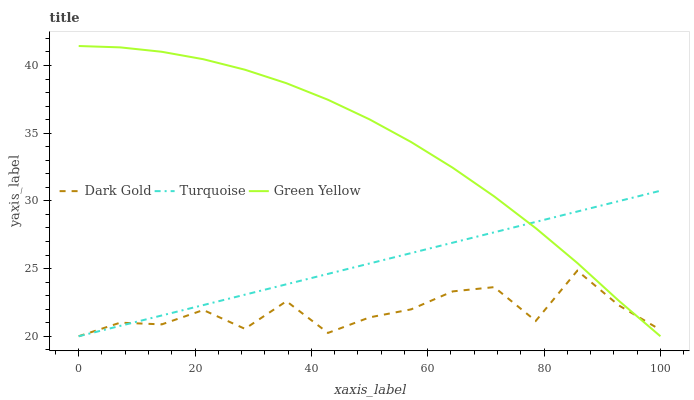Does Dark Gold have the minimum area under the curve?
Answer yes or no. Yes. Does Green Yellow have the maximum area under the curve?
Answer yes or no. Yes. Does Green Yellow have the minimum area under the curve?
Answer yes or no. No. Does Dark Gold have the maximum area under the curve?
Answer yes or no. No. Is Turquoise the smoothest?
Answer yes or no. Yes. Is Dark Gold the roughest?
Answer yes or no. Yes. Is Green Yellow the smoothest?
Answer yes or no. No. Is Green Yellow the roughest?
Answer yes or no. No. Does Turquoise have the lowest value?
Answer yes or no. Yes. Does Green Yellow have the highest value?
Answer yes or no. Yes. Does Dark Gold have the highest value?
Answer yes or no. No. Does Dark Gold intersect Turquoise?
Answer yes or no. Yes. Is Dark Gold less than Turquoise?
Answer yes or no. No. Is Dark Gold greater than Turquoise?
Answer yes or no. No. 